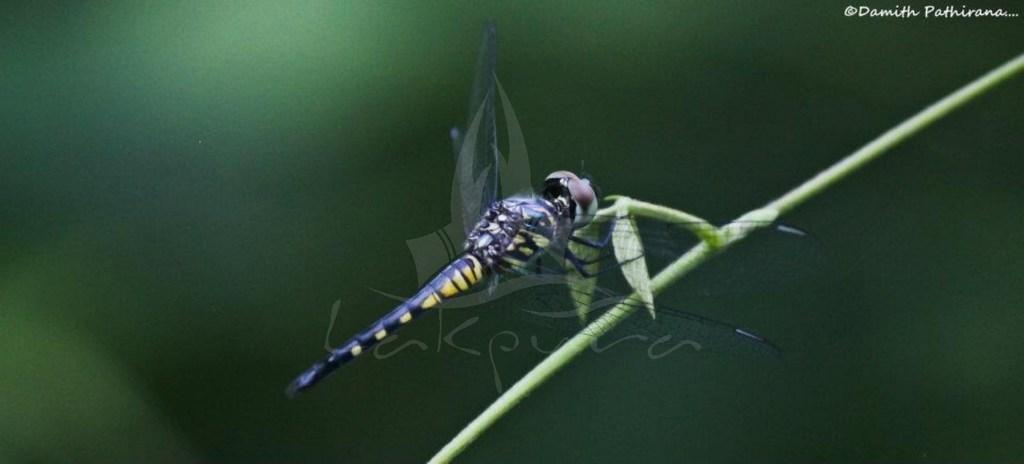What is the main subject of the image? There is a fly on a branch in the image. Can you describe the background of the image? The background of the image is blurred. Are there any words or letters on the image? Yes, there is text on the image. Is there any additional marking on the image? Yes, there is a watermark on the image. What type of popcorn is being served on the marble table in the image? There is no popcorn or marble table present in the image; it features a fly on a branch. Can you describe the loaf of bread on the marble table in the image? There is no loaf of bread or marble table present in the image. 